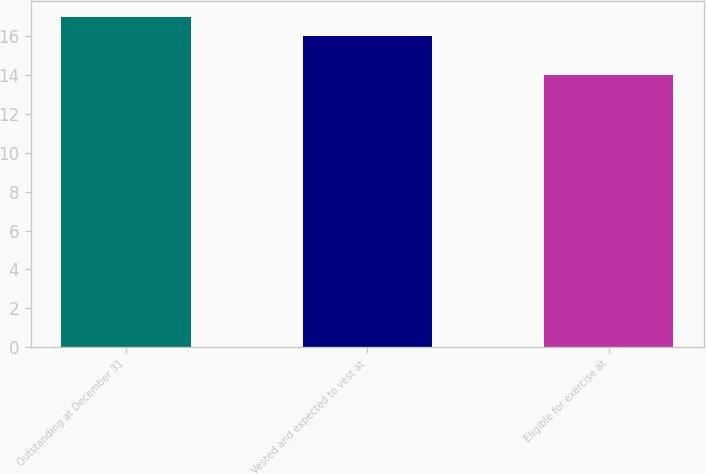Convert chart to OTSL. <chart><loc_0><loc_0><loc_500><loc_500><bar_chart><fcel>Outstanding at December 31<fcel>Vested and expected to vest at<fcel>Eligible for exercise at<nl><fcel>17<fcel>16<fcel>14<nl></chart> 